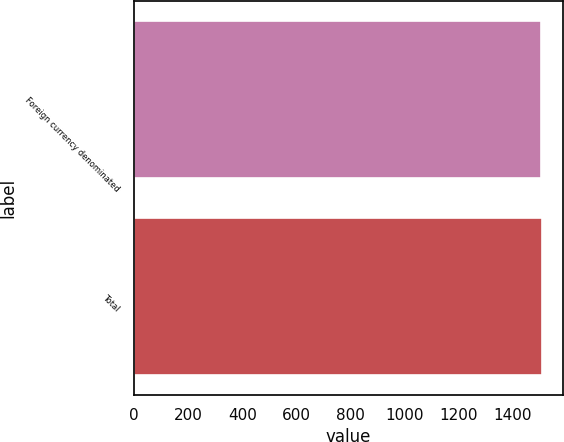Convert chart. <chart><loc_0><loc_0><loc_500><loc_500><bar_chart><fcel>Foreign currency denominated<fcel>Total<nl><fcel>1505<fcel>1512<nl></chart> 